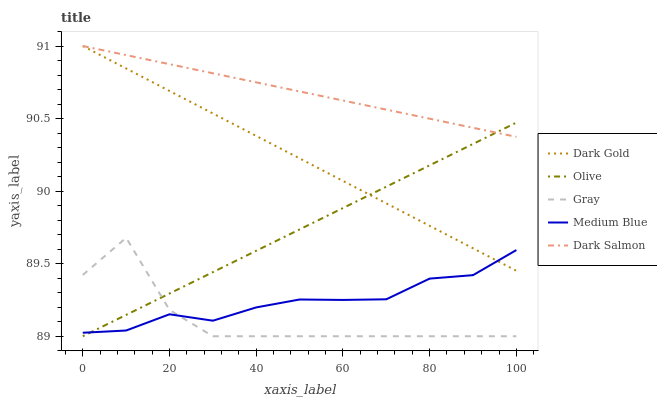Does Gray have the minimum area under the curve?
Answer yes or no. Yes. Does Dark Salmon have the maximum area under the curve?
Answer yes or no. Yes. Does Medium Blue have the minimum area under the curve?
Answer yes or no. No. Does Medium Blue have the maximum area under the curve?
Answer yes or no. No. Is Olive the smoothest?
Answer yes or no. Yes. Is Gray the roughest?
Answer yes or no. Yes. Is Medium Blue the smoothest?
Answer yes or no. No. Is Medium Blue the roughest?
Answer yes or no. No. Does Olive have the lowest value?
Answer yes or no. Yes. Does Medium Blue have the lowest value?
Answer yes or no. No. Does Dark Gold have the highest value?
Answer yes or no. Yes. Does Gray have the highest value?
Answer yes or no. No. Is Medium Blue less than Dark Salmon?
Answer yes or no. Yes. Is Dark Salmon greater than Medium Blue?
Answer yes or no. Yes. Does Dark Gold intersect Dark Salmon?
Answer yes or no. Yes. Is Dark Gold less than Dark Salmon?
Answer yes or no. No. Is Dark Gold greater than Dark Salmon?
Answer yes or no. No. Does Medium Blue intersect Dark Salmon?
Answer yes or no. No. 